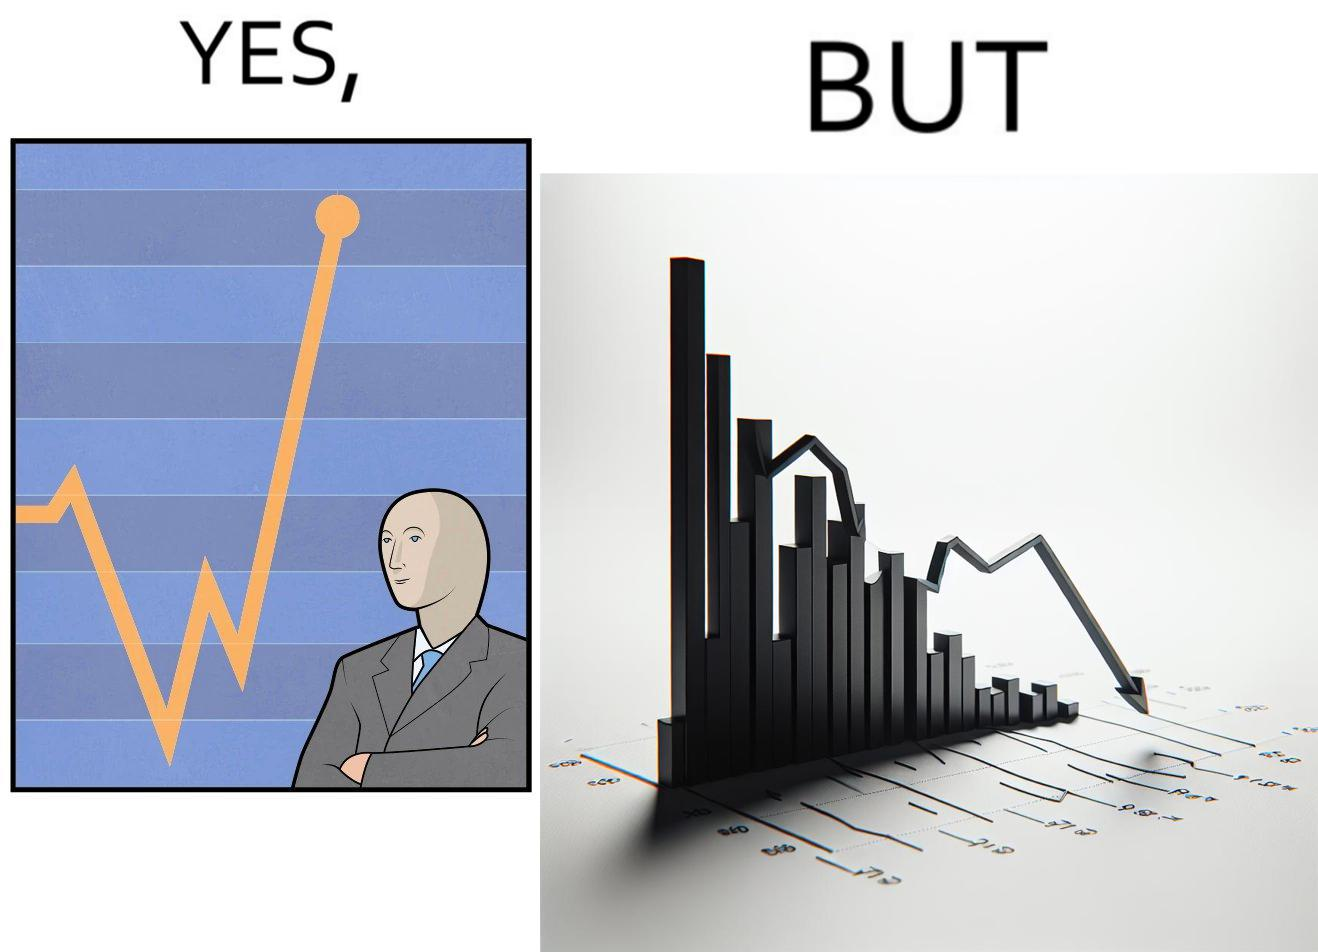Explain the humor or irony in this image. The image is ironic, because a person is seen feeling proud over the profit earned over his investment but the right image shows the whole story how only a small part of his investment journey is shown and the other loss part is ignored 